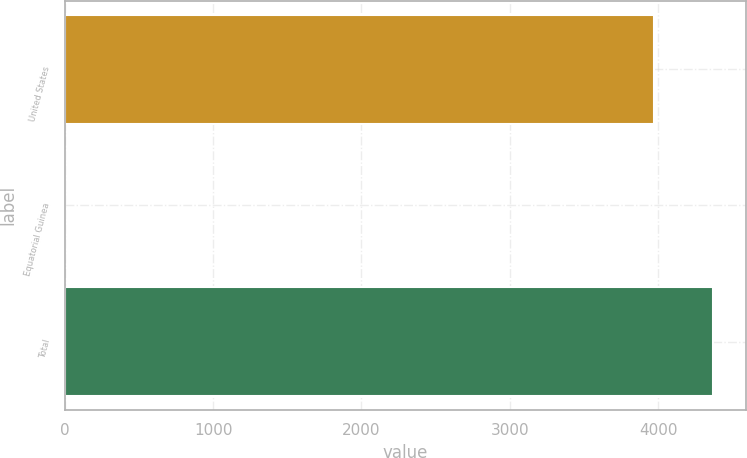<chart> <loc_0><loc_0><loc_500><loc_500><bar_chart><fcel>United States<fcel>Equatorial Guinea<fcel>Total<nl><fcel>3974<fcel>5<fcel>4371.4<nl></chart> 